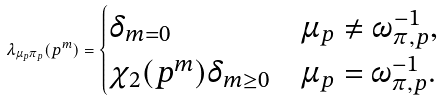Convert formula to latex. <formula><loc_0><loc_0><loc_500><loc_500>\lambda _ { \mu _ { p } \pi _ { p } } ( p ^ { m } ) = \begin{cases} \delta _ { m = 0 } & \mu _ { p } \neq \omega _ { \pi , p } ^ { - 1 } , \\ \chi _ { 2 } ( p ^ { m } ) \delta _ { m \geq 0 } & \mu _ { p } = \omega _ { \pi , p } ^ { - 1 } . \end{cases}</formula> 